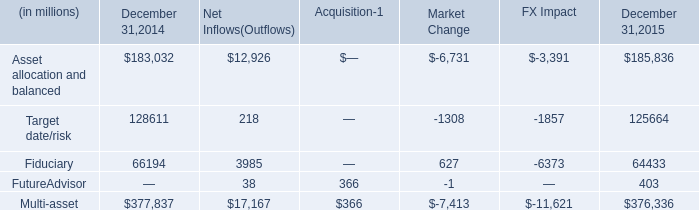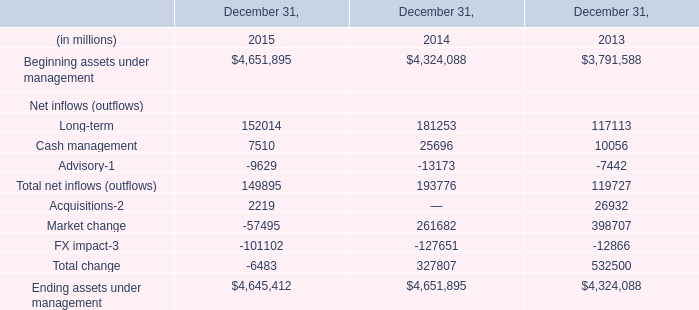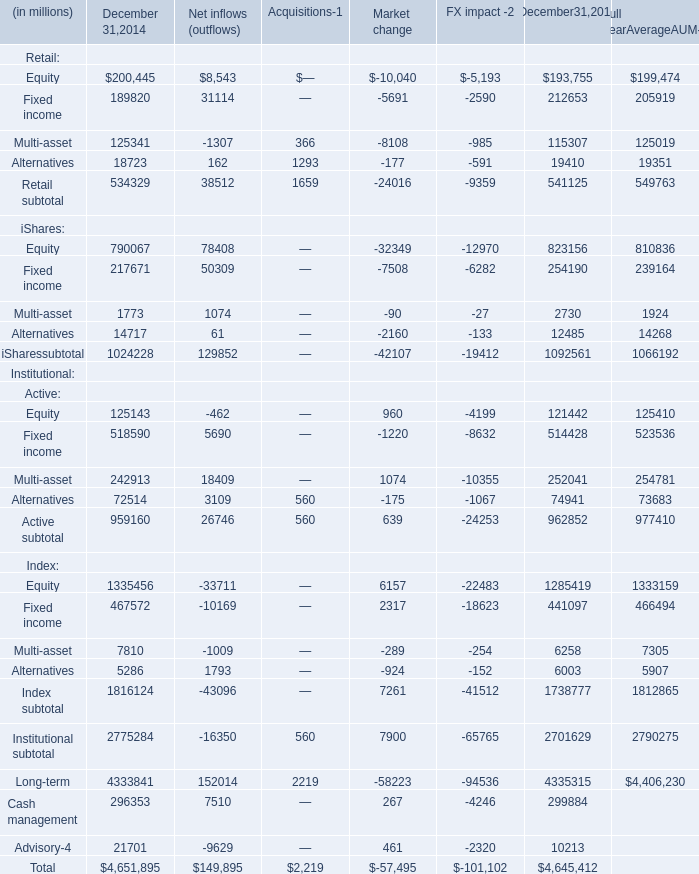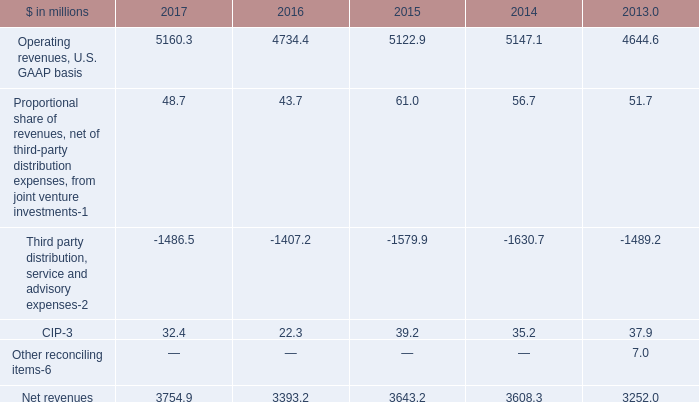What's the sum of net inflows (outflows) without Advisory smaller than 0, in 2015? (in dollars in millions) 
Computations: (152014 + 7510)
Answer: 159524.0. 